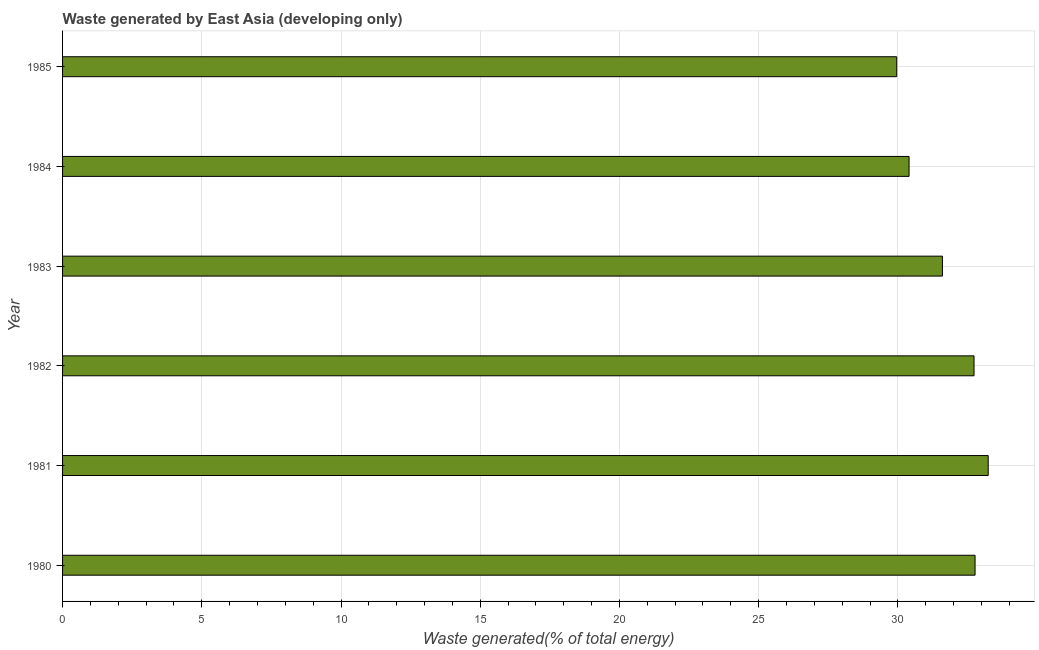What is the title of the graph?
Make the answer very short. Waste generated by East Asia (developing only). What is the label or title of the X-axis?
Provide a short and direct response. Waste generated(% of total energy). What is the amount of waste generated in 1983?
Offer a very short reply. 31.6. Across all years, what is the maximum amount of waste generated?
Keep it short and to the point. 33.24. Across all years, what is the minimum amount of waste generated?
Ensure brevity in your answer.  29.96. In which year was the amount of waste generated maximum?
Your response must be concise. 1981. What is the sum of the amount of waste generated?
Your answer should be compact. 190.71. What is the difference between the amount of waste generated in 1981 and 1983?
Your response must be concise. 1.64. What is the average amount of waste generated per year?
Your response must be concise. 31.79. What is the median amount of waste generated?
Provide a short and direct response. 32.17. Is the difference between the amount of waste generated in 1981 and 1982 greater than the difference between any two years?
Provide a succinct answer. No. What is the difference between the highest and the second highest amount of waste generated?
Give a very brief answer. 0.47. What is the difference between the highest and the lowest amount of waste generated?
Your answer should be very brief. 3.29. Are all the bars in the graph horizontal?
Your response must be concise. Yes. What is the Waste generated(% of total energy) in 1980?
Provide a succinct answer. 32.77. What is the Waste generated(% of total energy) of 1981?
Ensure brevity in your answer.  33.24. What is the Waste generated(% of total energy) in 1982?
Provide a succinct answer. 32.73. What is the Waste generated(% of total energy) in 1983?
Your answer should be very brief. 31.6. What is the Waste generated(% of total energy) of 1984?
Your answer should be very brief. 30.4. What is the Waste generated(% of total energy) of 1985?
Give a very brief answer. 29.96. What is the difference between the Waste generated(% of total energy) in 1980 and 1981?
Ensure brevity in your answer.  -0.47. What is the difference between the Waste generated(% of total energy) in 1980 and 1982?
Your answer should be very brief. 0.04. What is the difference between the Waste generated(% of total energy) in 1980 and 1983?
Keep it short and to the point. 1.17. What is the difference between the Waste generated(% of total energy) in 1980 and 1984?
Make the answer very short. 2.37. What is the difference between the Waste generated(% of total energy) in 1980 and 1985?
Make the answer very short. 2.81. What is the difference between the Waste generated(% of total energy) in 1981 and 1982?
Give a very brief answer. 0.51. What is the difference between the Waste generated(% of total energy) in 1981 and 1983?
Offer a terse response. 1.64. What is the difference between the Waste generated(% of total energy) in 1981 and 1984?
Make the answer very short. 2.84. What is the difference between the Waste generated(% of total energy) in 1981 and 1985?
Ensure brevity in your answer.  3.29. What is the difference between the Waste generated(% of total energy) in 1982 and 1983?
Provide a short and direct response. 1.14. What is the difference between the Waste generated(% of total energy) in 1982 and 1984?
Give a very brief answer. 2.33. What is the difference between the Waste generated(% of total energy) in 1982 and 1985?
Offer a very short reply. 2.78. What is the difference between the Waste generated(% of total energy) in 1983 and 1984?
Provide a short and direct response. 1.2. What is the difference between the Waste generated(% of total energy) in 1983 and 1985?
Your answer should be very brief. 1.64. What is the difference between the Waste generated(% of total energy) in 1984 and 1985?
Make the answer very short. 0.44. What is the ratio of the Waste generated(% of total energy) in 1980 to that in 1981?
Provide a short and direct response. 0.99. What is the ratio of the Waste generated(% of total energy) in 1980 to that in 1982?
Make the answer very short. 1. What is the ratio of the Waste generated(% of total energy) in 1980 to that in 1984?
Ensure brevity in your answer.  1.08. What is the ratio of the Waste generated(% of total energy) in 1980 to that in 1985?
Your answer should be compact. 1.09. What is the ratio of the Waste generated(% of total energy) in 1981 to that in 1982?
Provide a short and direct response. 1.02. What is the ratio of the Waste generated(% of total energy) in 1981 to that in 1983?
Your answer should be compact. 1.05. What is the ratio of the Waste generated(% of total energy) in 1981 to that in 1984?
Make the answer very short. 1.09. What is the ratio of the Waste generated(% of total energy) in 1981 to that in 1985?
Your answer should be very brief. 1.11. What is the ratio of the Waste generated(% of total energy) in 1982 to that in 1983?
Provide a short and direct response. 1.04. What is the ratio of the Waste generated(% of total energy) in 1982 to that in 1984?
Ensure brevity in your answer.  1.08. What is the ratio of the Waste generated(% of total energy) in 1982 to that in 1985?
Your answer should be compact. 1.09. What is the ratio of the Waste generated(% of total energy) in 1983 to that in 1984?
Provide a succinct answer. 1.04. What is the ratio of the Waste generated(% of total energy) in 1983 to that in 1985?
Your response must be concise. 1.05. 